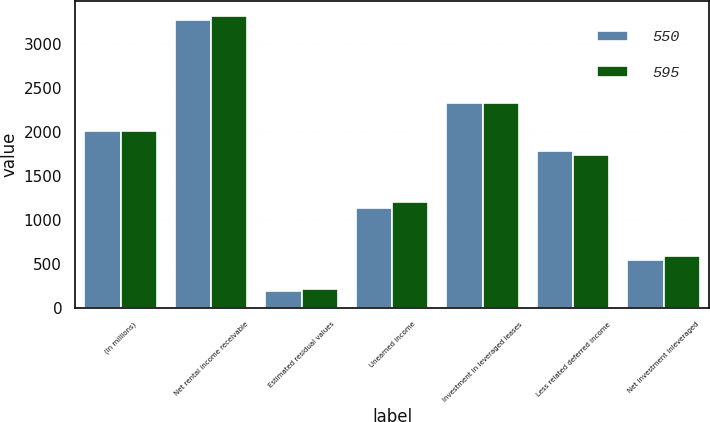<chart> <loc_0><loc_0><loc_500><loc_500><stacked_bar_chart><ecel><fcel>(In millions)<fcel>Net rental income receivable<fcel>Estimated residual values<fcel>Unearned income<fcel>Investment in leveraged leases<fcel>Less related deferred income<fcel>Net investment inleveraged<nl><fcel>550<fcel>2006<fcel>3272<fcel>196<fcel>1139<fcel>2329<fcel>1779<fcel>550<nl><fcel>595<fcel>2005<fcel>3314<fcel>215<fcel>1199<fcel>2330<fcel>1735<fcel>595<nl></chart> 